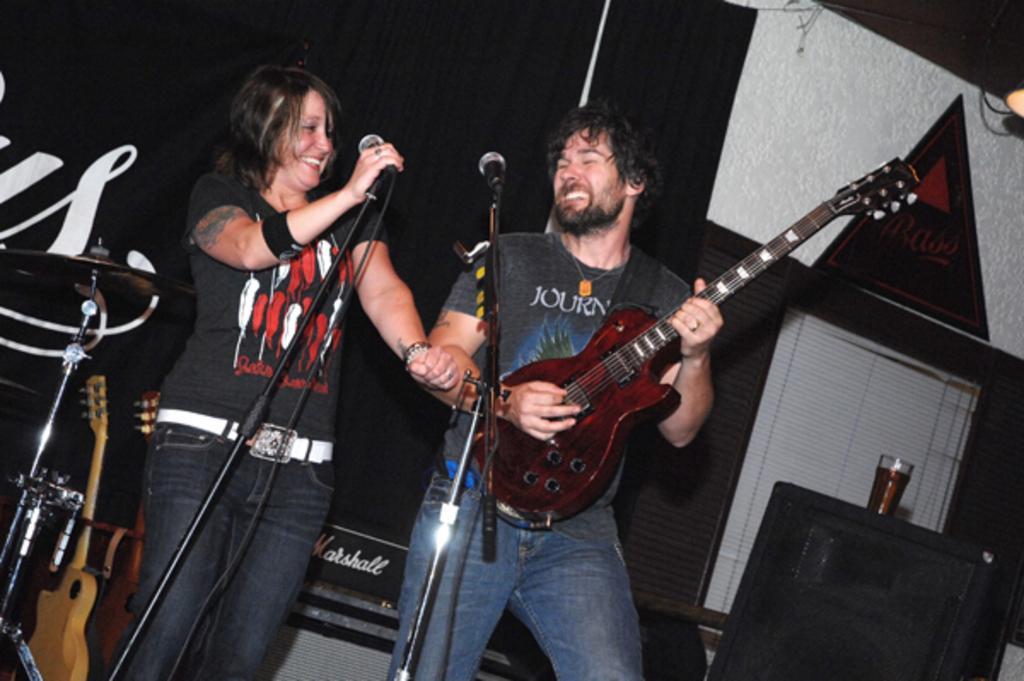Can you describe this image briefly? In this image I can see two people standing in-front of the mic. Among them one person is holding the guitar. 